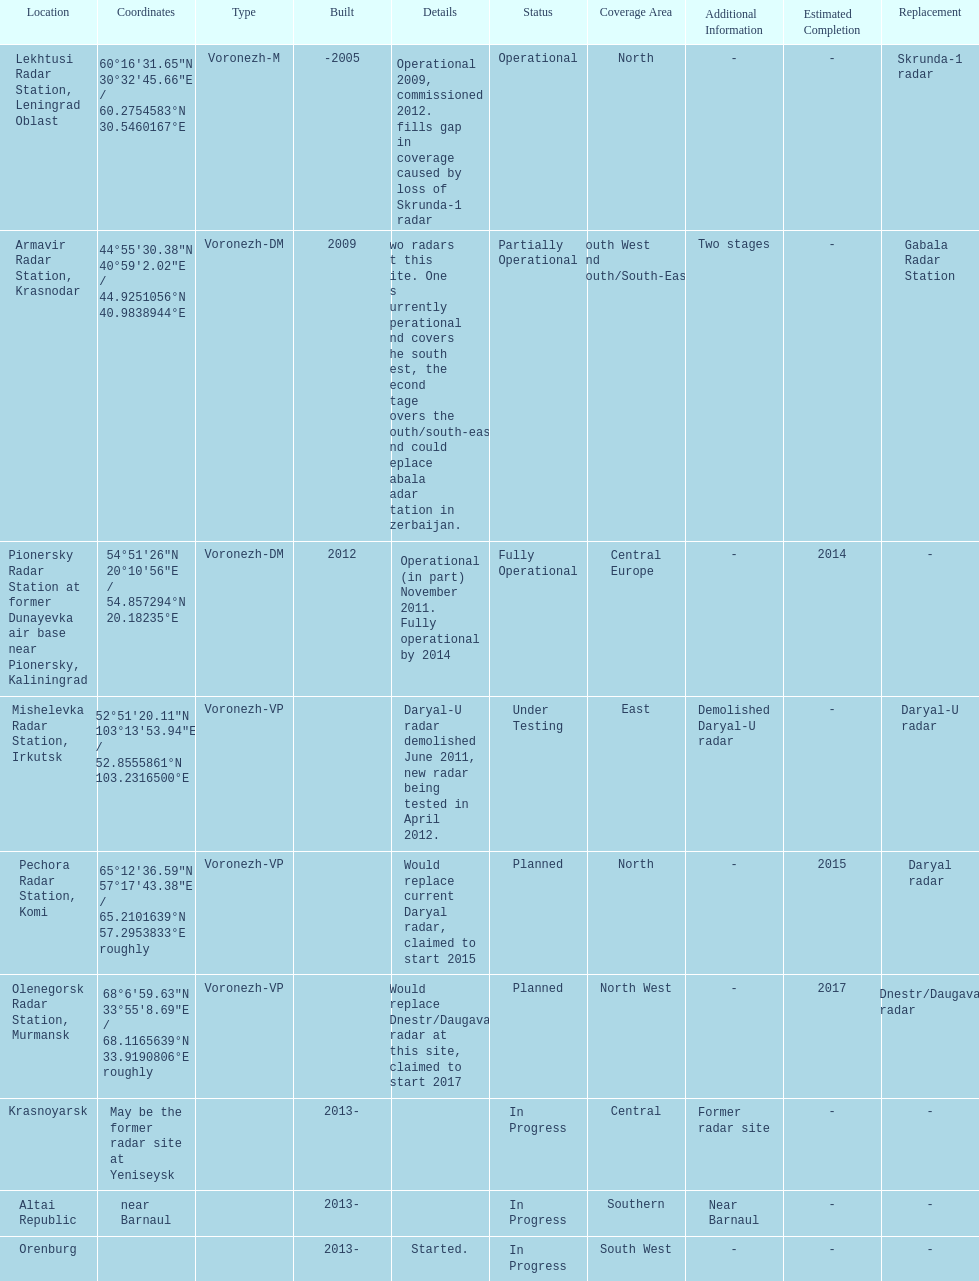Which site has the most radars? Armavir Radar Station, Krasnodar. 